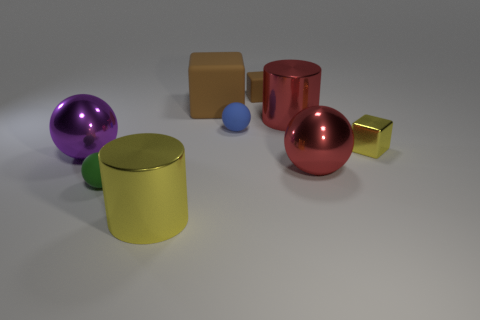Subtract all small blue balls. How many balls are left? 3 Add 1 large spheres. How many objects exist? 10 Subtract all brown blocks. How many blocks are left? 1 Subtract all balls. How many objects are left? 5 Subtract all gray cubes. Subtract all cyan cylinders. How many cubes are left? 3 Subtract all blue blocks. How many cyan cylinders are left? 0 Subtract all red shiny cylinders. Subtract all red objects. How many objects are left? 6 Add 3 small brown blocks. How many small brown blocks are left? 4 Add 5 large blue things. How many large blue things exist? 5 Subtract 0 green cylinders. How many objects are left? 9 